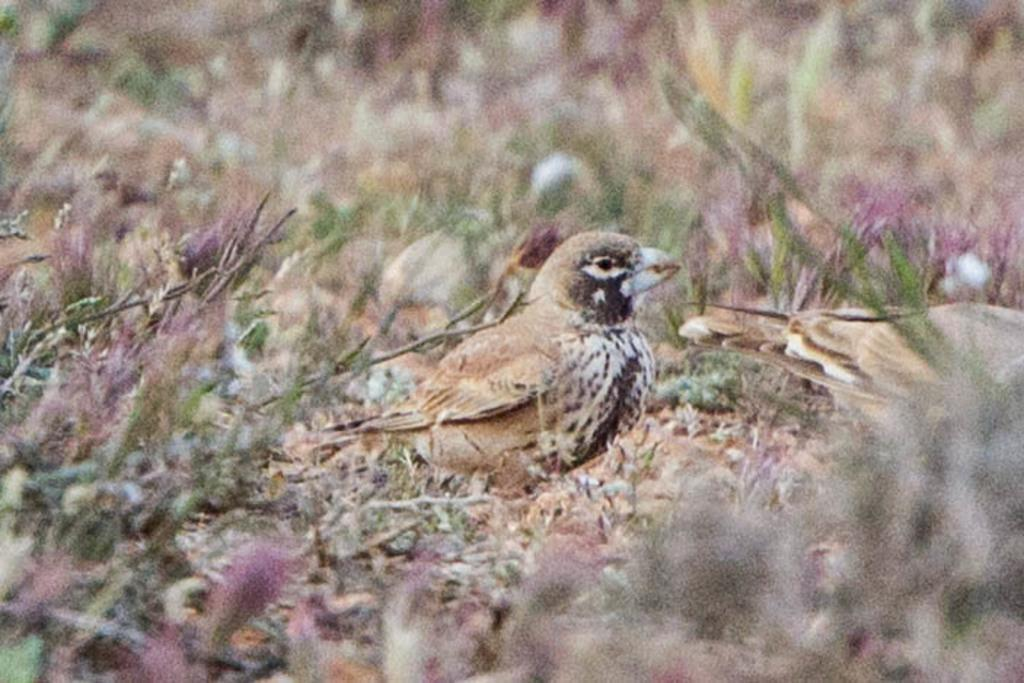What type of vegetation is at the bottom of the image? There is grass at the bottom of the image. What animal can be seen in the middle of the image? There is a bird in the middle of the image. How many trucks are visible in the image? There are no trucks present in the image. What type of waste can be seen in the image? There is no waste visible in the image. 